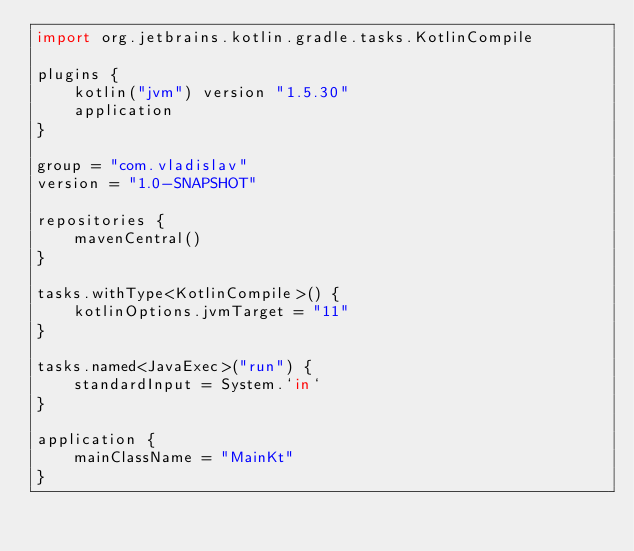<code> <loc_0><loc_0><loc_500><loc_500><_Kotlin_>import org.jetbrains.kotlin.gradle.tasks.KotlinCompile

plugins {
    kotlin("jvm") version "1.5.30"
    application
}

group = "com.vladislav"
version = "1.0-SNAPSHOT"

repositories {
    mavenCentral()
}

tasks.withType<KotlinCompile>() {
    kotlinOptions.jvmTarget = "11"
}

tasks.named<JavaExec>("run") {
    standardInput = System.`in`
}

application {
    mainClassName = "MainKt"
}</code> 